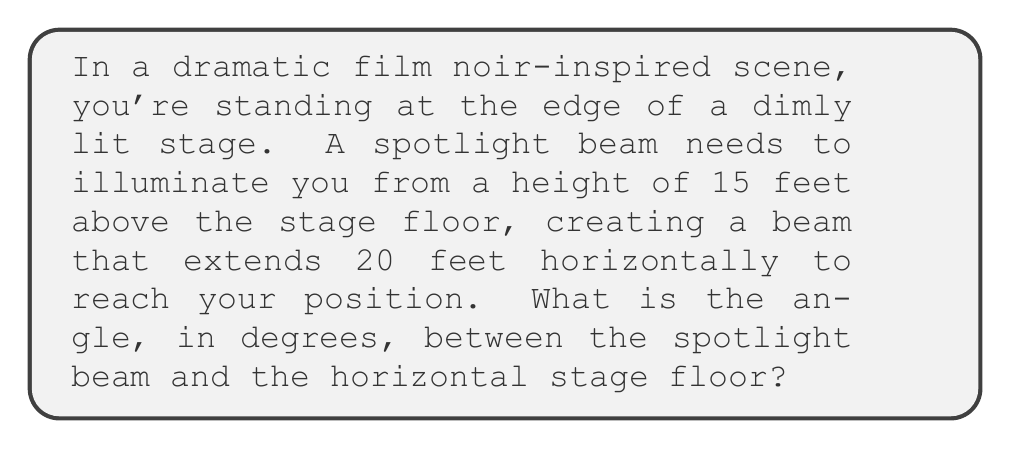Give your solution to this math problem. Let's approach this step-by-step using trigonometry:

1) We can visualize this scenario as a right triangle, where:
   - The vertical height of the spotlight is the opposite side (15 feet)
   - The horizontal distance to your position is the adjacent side (20 feet)
   - The spotlight beam forms the hypotenuse
   - The angle we're looking for is between the beam and the stage floor

2) To find this angle, we can use the tangent function:

   $$\tan(\theta) = \frac{\text{opposite}}{\text{adjacent}}$$

3) Plugging in our values:

   $$\tan(\theta) = \frac{15}{20}$$

4) To solve for $\theta$, we need to use the inverse tangent (arctan or $\tan^{-1}$):

   $$\theta = \tan^{-1}\left(\frac{15}{20}\right)$$

5) Using a calculator or computer:

   $$\theta = \tan^{-1}(0.75) \approx 36.87\text{°}$$

6) Rounding to two decimal places:

   $$\theta \approx 36.87\text{°}$$

[asy]
import geometry;

size(200);
pair A=(0,0), B=(20,0), C=(0,15);
draw(A--B--C--A);
draw(A--(20,15),arrow=Arrow(TeXHead));
label("20 ft",B,(0,-1));
label("15 ft",C,W);
label("$\theta$",(0,0),NE);
dot("You",B,SE);
dot("Spotlight",C,NW);
[/asy]
Answer: $36.87\text{°}$ 